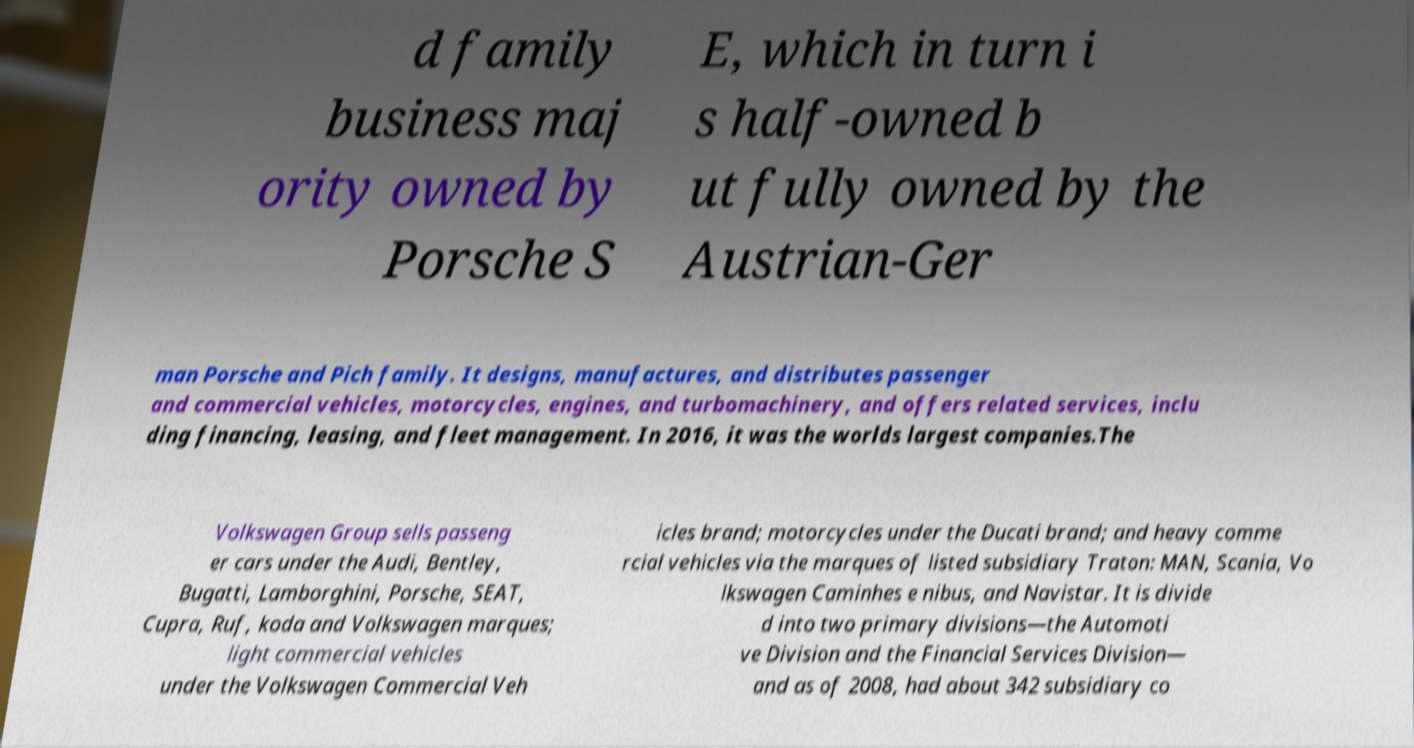Please read and relay the text visible in this image. What does it say? d family business maj ority owned by Porsche S E, which in turn i s half-owned b ut fully owned by the Austrian-Ger man Porsche and Pich family. It designs, manufactures, and distributes passenger and commercial vehicles, motorcycles, engines, and turbomachinery, and offers related services, inclu ding financing, leasing, and fleet management. In 2016, it was the worlds largest companies.The Volkswagen Group sells passeng er cars under the Audi, Bentley, Bugatti, Lamborghini, Porsche, SEAT, Cupra, Ruf, koda and Volkswagen marques; light commercial vehicles under the Volkswagen Commercial Veh icles brand; motorcycles under the Ducati brand; and heavy comme rcial vehicles via the marques of listed subsidiary Traton: MAN, Scania, Vo lkswagen Caminhes e nibus, and Navistar. It is divide d into two primary divisions—the Automoti ve Division and the Financial Services Division— and as of 2008, had about 342 subsidiary co 